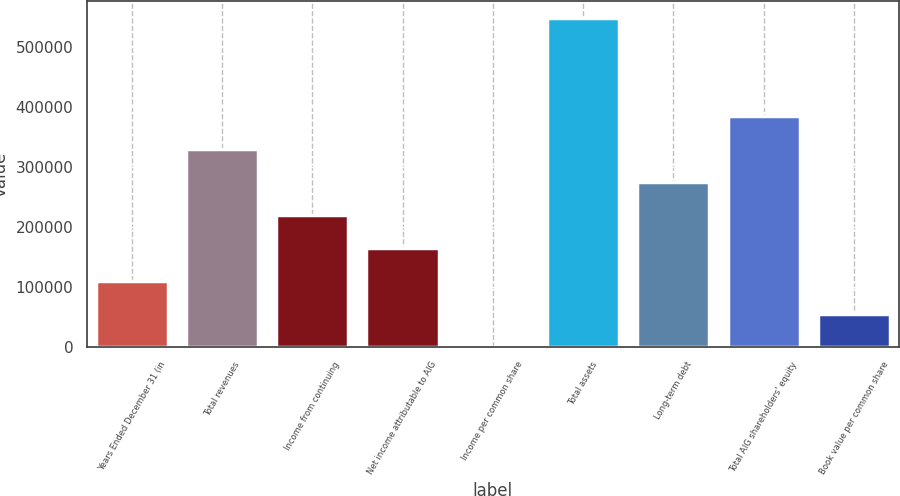Convert chart to OTSL. <chart><loc_0><loc_0><loc_500><loc_500><bar_chart><fcel>Years Ended December 31 (in<fcel>Total revenues<fcel>Income from continuing<fcel>Net income attributable to AIG<fcel>Income per common share<fcel>Total assets<fcel>Long-term debt<fcel>Total AIG shareholders' equity<fcel>Book value per common share<nl><fcel>109728<fcel>329181<fcel>219454<fcel>164591<fcel>2.04<fcel>548633<fcel>274318<fcel>384044<fcel>54865.1<nl></chart> 